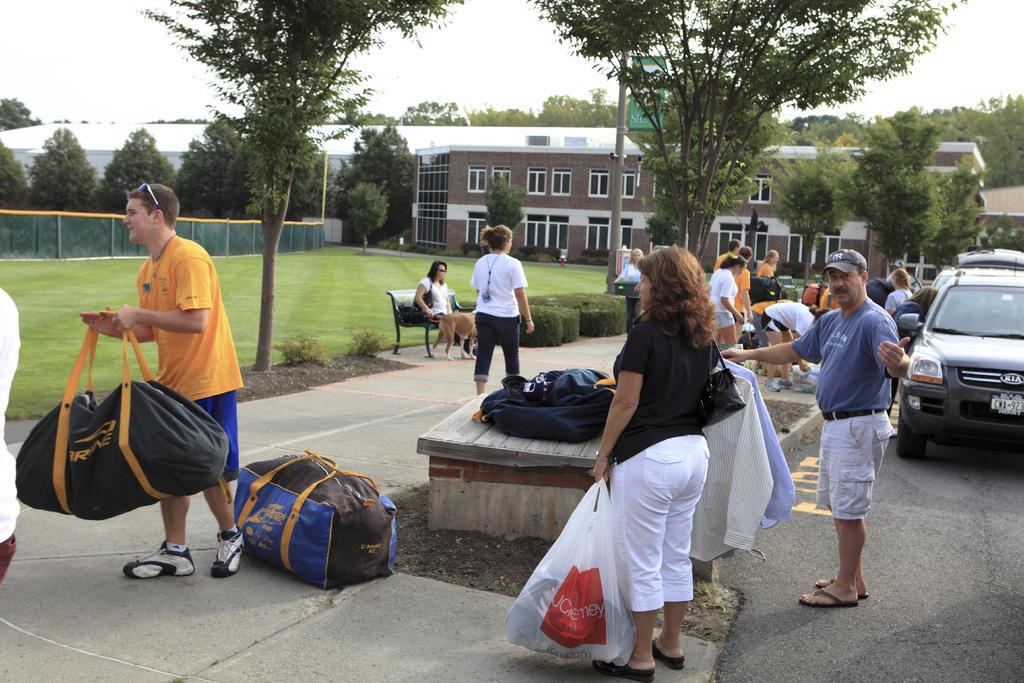In one or two sentences, can you explain what this image depicts? In this image, we can see people and some are wearing bags and holding objects and there is a person wearing a cap and we can see some bags, trees, sheds, poles, a fence, boards and there are vehicles on the road. At the top, there is sky. 